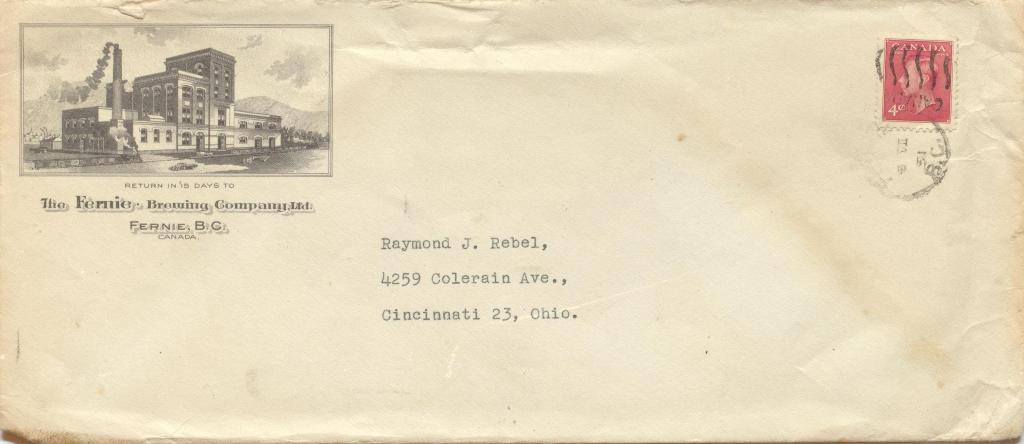Who sent the letter?
Offer a very short reply. Unanswerable. Where is the letter being sent to?
Provide a succinct answer. Ohio. 